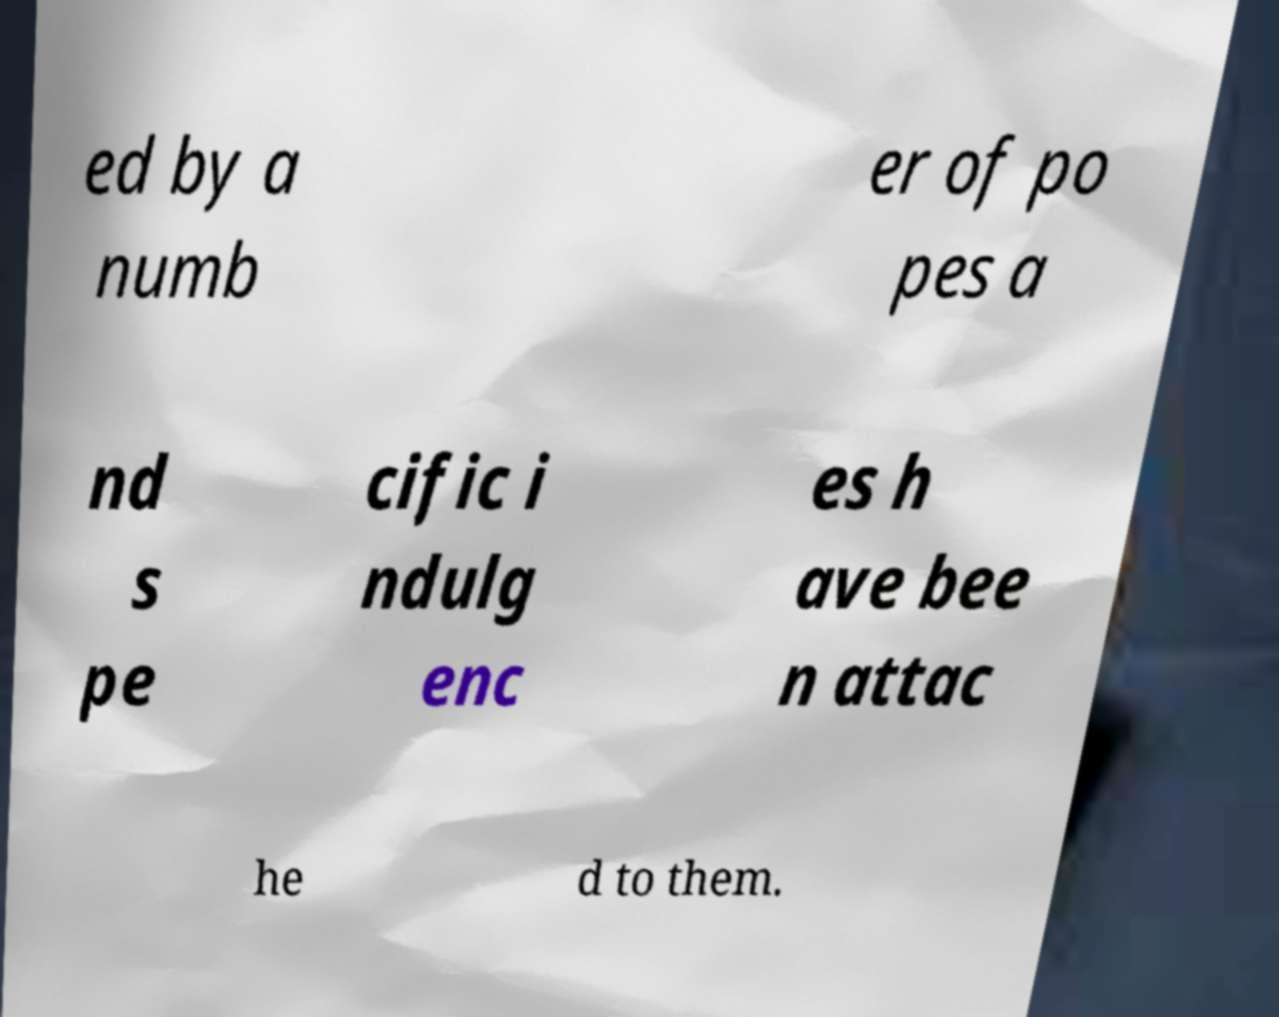Please read and relay the text visible in this image. What does it say? ed by a numb er of po pes a nd s pe cific i ndulg enc es h ave bee n attac he d to them. 